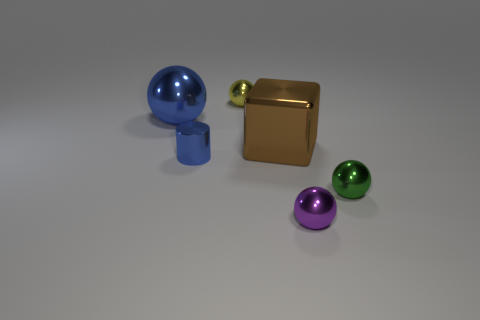Add 1 cyan objects. How many objects exist? 7 Subtract all green shiny spheres. How many spheres are left? 3 Subtract all spheres. How many objects are left? 2 Subtract all green spheres. How many spheres are left? 3 Subtract 2 spheres. How many spheres are left? 2 Subtract 0 gray blocks. How many objects are left? 6 Subtract all green blocks. Subtract all brown spheres. How many blocks are left? 1 Subtract all big gray shiny cubes. Subtract all blue spheres. How many objects are left? 5 Add 4 small green metallic objects. How many small green metallic objects are left? 5 Add 3 brown things. How many brown things exist? 4 